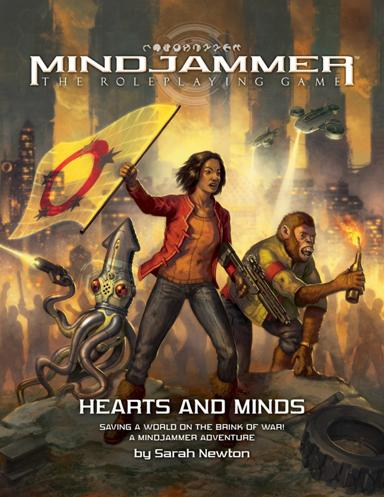Can you describe the setting depicted in the cover art? The cover art of 'Mindjammer' showcases a dynamic and potentially dystopian world. The background features advanced, yet war-torn cityscapes, suggesting the game’s setting might involve exploring these complex environments. The mix of old and futuristic elements like the floating holograms and traditional clothing hints at a culturally diverse world, rich in history but facing modern conflicts. 